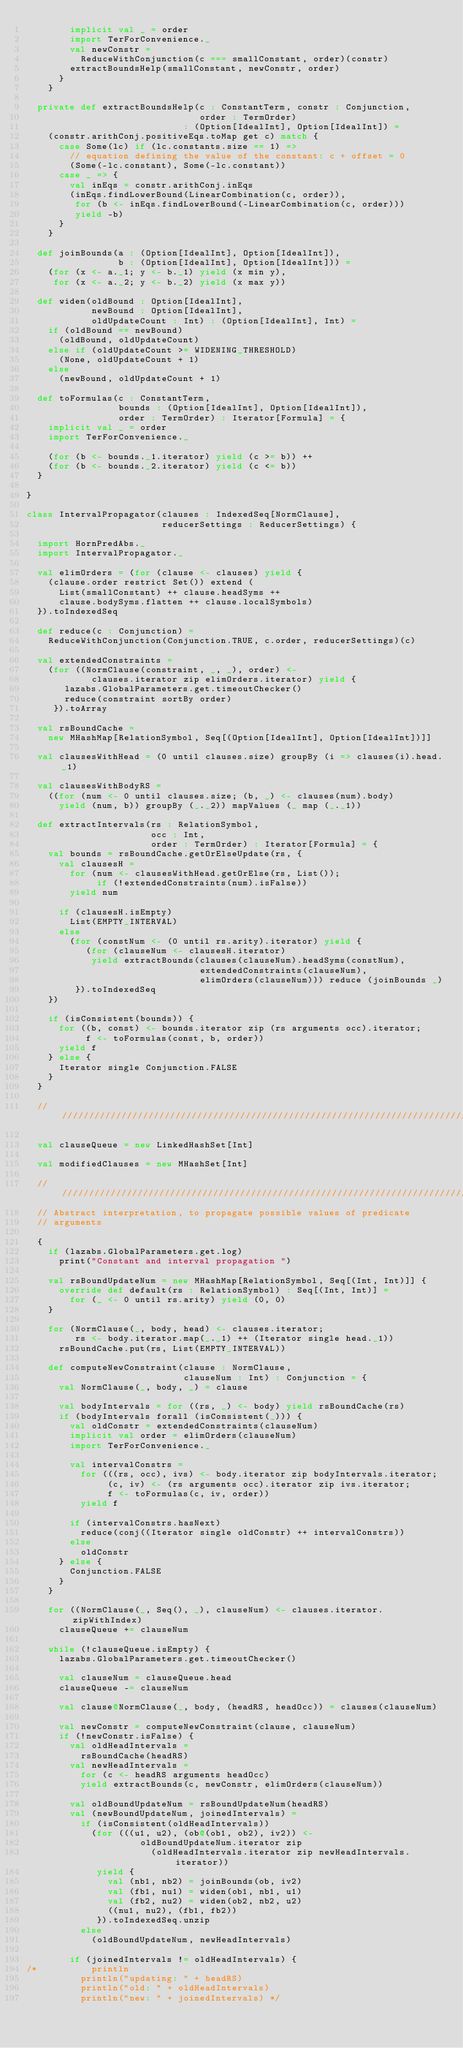Convert code to text. <code><loc_0><loc_0><loc_500><loc_500><_Scala_>        implicit val _ = order
        import TerForConvenience._
        val newConstr =
          ReduceWithConjunction(c === smallConstant, order)(constr)
        extractBoundsHelp(smallConstant, newConstr, order)
      }
    }

  private def extractBoundsHelp(c : ConstantTerm, constr : Conjunction,
                                order : TermOrder)
                             : (Option[IdealInt], Option[IdealInt]) =
    (constr.arithConj.positiveEqs.toMap get c) match {
      case Some(lc) if (lc.constants.size == 1) =>
        // equation defining the value of the constant: c + offset = 0
        (Some(-lc.constant), Some(-lc.constant))
      case _ => {
        val inEqs = constr.arithConj.inEqs
        (inEqs.findLowerBound(LinearCombination(c, order)),
         for (b <- inEqs.findLowerBound(-LinearCombination(c, order)))
         yield -b)
      }
    }

  def joinBounds(a : (Option[IdealInt], Option[IdealInt]),
                 b : (Option[IdealInt], Option[IdealInt])) =
    (for (x <- a._1; y <- b._1) yield (x min y),
     for (x <- a._2; y <- b._2) yield (x max y))

  def widen(oldBound : Option[IdealInt],
            newBound : Option[IdealInt],
            oldUpdateCount : Int) : (Option[IdealInt], Int) =
    if (oldBound == newBound)
      (oldBound, oldUpdateCount)
    else if (oldUpdateCount >= WIDENING_THRESHOLD)
      (None, oldUpdateCount + 1)
    else
      (newBound, oldUpdateCount + 1)

  def toFormulas(c : ConstantTerm,
                 bounds : (Option[IdealInt], Option[IdealInt]),
                 order : TermOrder) : Iterator[Formula] = {
    implicit val _ = order
    import TerForConvenience._

    (for (b <- bounds._1.iterator) yield (c >= b)) ++
    (for (b <- bounds._2.iterator) yield (c <= b))
  }

}

class IntervalPropagator(clauses : IndexedSeq[NormClause],
                         reducerSettings : ReducerSettings) {

  import HornPredAbs._
  import IntervalPropagator._

  val elimOrders = (for (clause <- clauses) yield {
    (clause.order restrict Set()) extend (
      List(smallConstant) ++ clause.headSyms ++
      clause.bodySyms.flatten ++ clause.localSymbols)
  }).toIndexedSeq

  def reduce(c : Conjunction) =
    ReduceWithConjunction(Conjunction.TRUE, c.order, reducerSettings)(c)

  val extendedConstraints =
    (for ((NormClause(constraint, _, _), order) <-
            clauses.iterator zip elimOrders.iterator) yield {
       lazabs.GlobalParameters.get.timeoutChecker()
       reduce(constraint sortBy order)
     }).toArray

  val rsBoundCache =
    new MHashMap[RelationSymbol, Seq[(Option[IdealInt], Option[IdealInt])]]

  val clausesWithHead = (0 until clauses.size) groupBy (i => clauses(i).head._1)

  val clausesWithBodyRS =
    ((for (num <- 0 until clauses.size; (b, _) <- clauses(num).body)
      yield (num, b)) groupBy (_._2)) mapValues (_ map (_._1))

  def extractIntervals(rs : RelationSymbol,
                       occ : Int,
                       order : TermOrder) : Iterator[Formula] = {
    val bounds = rsBoundCache.getOrElseUpdate(rs, {
      val clausesH =
        for (num <- clausesWithHead.getOrElse(rs, List());
             if (!extendedConstraints(num).isFalse))
        yield num

      if (clausesH.isEmpty)
        List(EMPTY_INTERVAL)
      else
        (for (constNum <- (0 until rs.arity).iterator) yield {
           (for (clauseNum <- clausesH.iterator)
            yield extractBounds(clauses(clauseNum).headSyms(constNum),
                                extendedConstraints(clauseNum),
                                elimOrders(clauseNum))) reduce (joinBounds _)
         }).toIndexedSeq
    })

    if (isConsistent(bounds)) {
      for ((b, const) <- bounds.iterator zip (rs arguments occ).iterator;
           f <- toFormulas(const, b, order))
      yield f
    } else {
      Iterator single Conjunction.FALSE
    }
  }

  //////////////////////////////////////////////////////////////////////////////

  val clauseQueue = new LinkedHashSet[Int]

  val modifiedClauses = new MHashSet[Int]

  //////////////////////////////////////////////////////////////////////////////
  // Abstract interpretation, to propagate possible values of predicate
  // arguments

  {
    if (lazabs.GlobalParameters.get.log)
      print("Constant and interval propagation ")

    val rsBoundUpdateNum = new MHashMap[RelationSymbol, Seq[(Int, Int)]] {
      override def default(rs : RelationSymbol) : Seq[(Int, Int)] =
        for (_ <- 0 until rs.arity) yield (0, 0)
    }

    for (NormClause(_, body, head) <- clauses.iterator;
         rs <- body.iterator.map(_._1) ++ (Iterator single head._1))
      rsBoundCache.put(rs, List(EMPTY_INTERVAL))

    def computeNewConstraint(clause : NormClause,
                             clauseNum : Int) : Conjunction = {
      val NormClause(_, body, _) = clause

      val bodyIntervals = for ((rs, _) <- body) yield rsBoundCache(rs)
      if (bodyIntervals forall (isConsistent(_))) {
        val oldConstr = extendedConstraints(clauseNum)
        implicit val order = elimOrders(clauseNum)
        import TerForConvenience._

        val intervalConstrs =
          for (((rs, occ), ivs) <- body.iterator zip bodyIntervals.iterator;
               (c, iv) <- (rs arguments occ).iterator zip ivs.iterator;
               f <- toFormulas(c, iv, order))
          yield f

        if (intervalConstrs.hasNext)
          reduce(conj((Iterator single oldConstr) ++ intervalConstrs))
        else
          oldConstr
      } else {
        Conjunction.FALSE
      }
    }

    for ((NormClause(_, Seq(), _), clauseNum) <- clauses.iterator.zipWithIndex)
      clauseQueue += clauseNum

    while (!clauseQueue.isEmpty) {
      lazabs.GlobalParameters.get.timeoutChecker()

      val clauseNum = clauseQueue.head
      clauseQueue -= clauseNum

      val clause@NormClause(_, body, (headRS, headOcc)) = clauses(clauseNum)

      val newConstr = computeNewConstraint(clause, clauseNum)
      if (!newConstr.isFalse) {
        val oldHeadIntervals =
          rsBoundCache(headRS)
        val newHeadIntervals =
          for (c <- headRS arguments headOcc)
          yield extractBounds(c, newConstr, elimOrders(clauseNum))

        val oldBoundUpdateNum = rsBoundUpdateNum(headRS)
        val (newBoundUpdateNum, joinedIntervals) =
          if (isConsistent(oldHeadIntervals))
            (for (((u1, u2), (ob@(ob1, ob2), iv2)) <-
                     oldBoundUpdateNum.iterator zip
                       (oldHeadIntervals.iterator zip newHeadIntervals.iterator))
             yield {
               val (nb1, nb2) = joinBounds(ob, iv2)
               val (fb1, nu1) = widen(ob1, nb1, u1)
               val (fb2, nu2) = widen(ob2, nb2, u2)
               ((nu1, nu2), (fb1, fb2))
             }).toIndexedSeq.unzip
          else
            (oldBoundUpdateNum, newHeadIntervals)

        if (joinedIntervals != oldHeadIntervals) {
/*          println
          println("updating: " + headRS)
          println("old: " + oldHeadIntervals)
          println("new: " + joinedIntervals) */</code> 